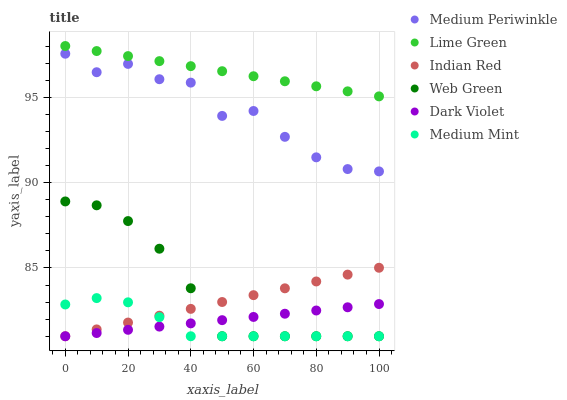Does Medium Mint have the minimum area under the curve?
Answer yes or no. Yes. Does Lime Green have the maximum area under the curve?
Answer yes or no. Yes. Does Medium Periwinkle have the minimum area under the curve?
Answer yes or no. No. Does Medium Periwinkle have the maximum area under the curve?
Answer yes or no. No. Is Dark Violet the smoothest?
Answer yes or no. Yes. Is Medium Periwinkle the roughest?
Answer yes or no. Yes. Is Medium Periwinkle the smoothest?
Answer yes or no. No. Is Dark Violet the roughest?
Answer yes or no. No. Does Medium Mint have the lowest value?
Answer yes or no. Yes. Does Medium Periwinkle have the lowest value?
Answer yes or no. No. Does Lime Green have the highest value?
Answer yes or no. Yes. Does Medium Periwinkle have the highest value?
Answer yes or no. No. Is Dark Violet less than Lime Green?
Answer yes or no. Yes. Is Lime Green greater than Medium Mint?
Answer yes or no. Yes. Does Medium Mint intersect Indian Red?
Answer yes or no. Yes. Is Medium Mint less than Indian Red?
Answer yes or no. No. Is Medium Mint greater than Indian Red?
Answer yes or no. No. Does Dark Violet intersect Lime Green?
Answer yes or no. No. 